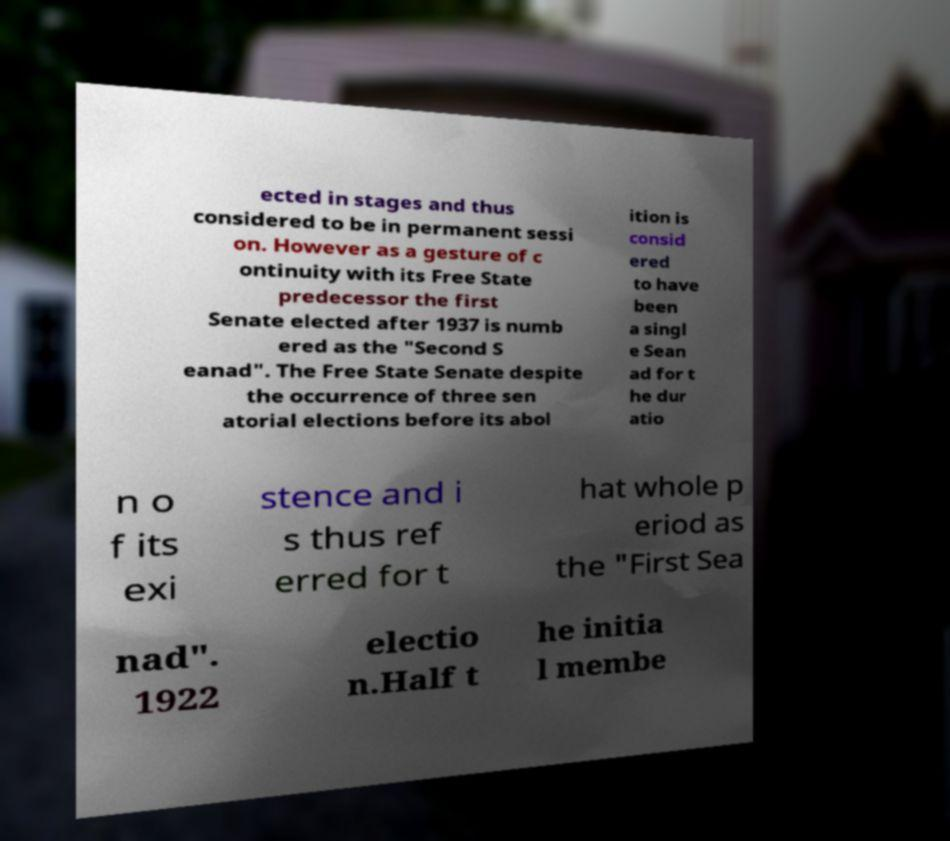What messages or text are displayed in this image? I need them in a readable, typed format. ected in stages and thus considered to be in permanent sessi on. However as a gesture of c ontinuity with its Free State predecessor the first Senate elected after 1937 is numb ered as the "Second S eanad". The Free State Senate despite the occurrence of three sen atorial elections before its abol ition is consid ered to have been a singl e Sean ad for t he dur atio n o f its exi stence and i s thus ref erred for t hat whole p eriod as the "First Sea nad". 1922 electio n.Half t he initia l membe 